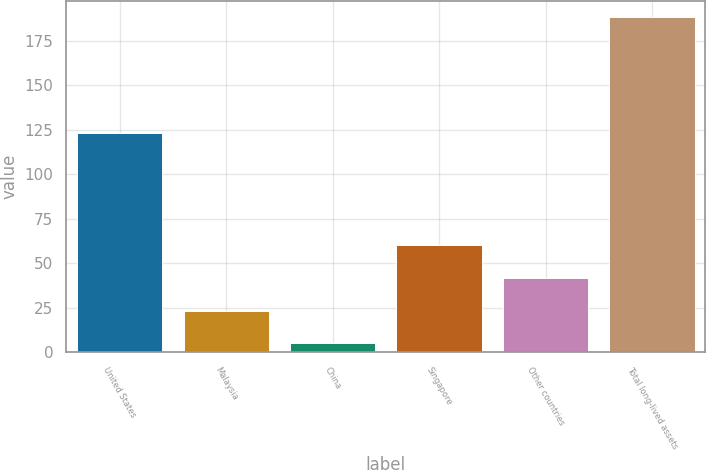Convert chart to OTSL. <chart><loc_0><loc_0><loc_500><loc_500><bar_chart><fcel>United States<fcel>Malaysia<fcel>China<fcel>Singapore<fcel>Other countries<fcel>Total long-lived assets<nl><fcel>123<fcel>23.3<fcel>5<fcel>59.9<fcel>41.6<fcel>188<nl></chart> 